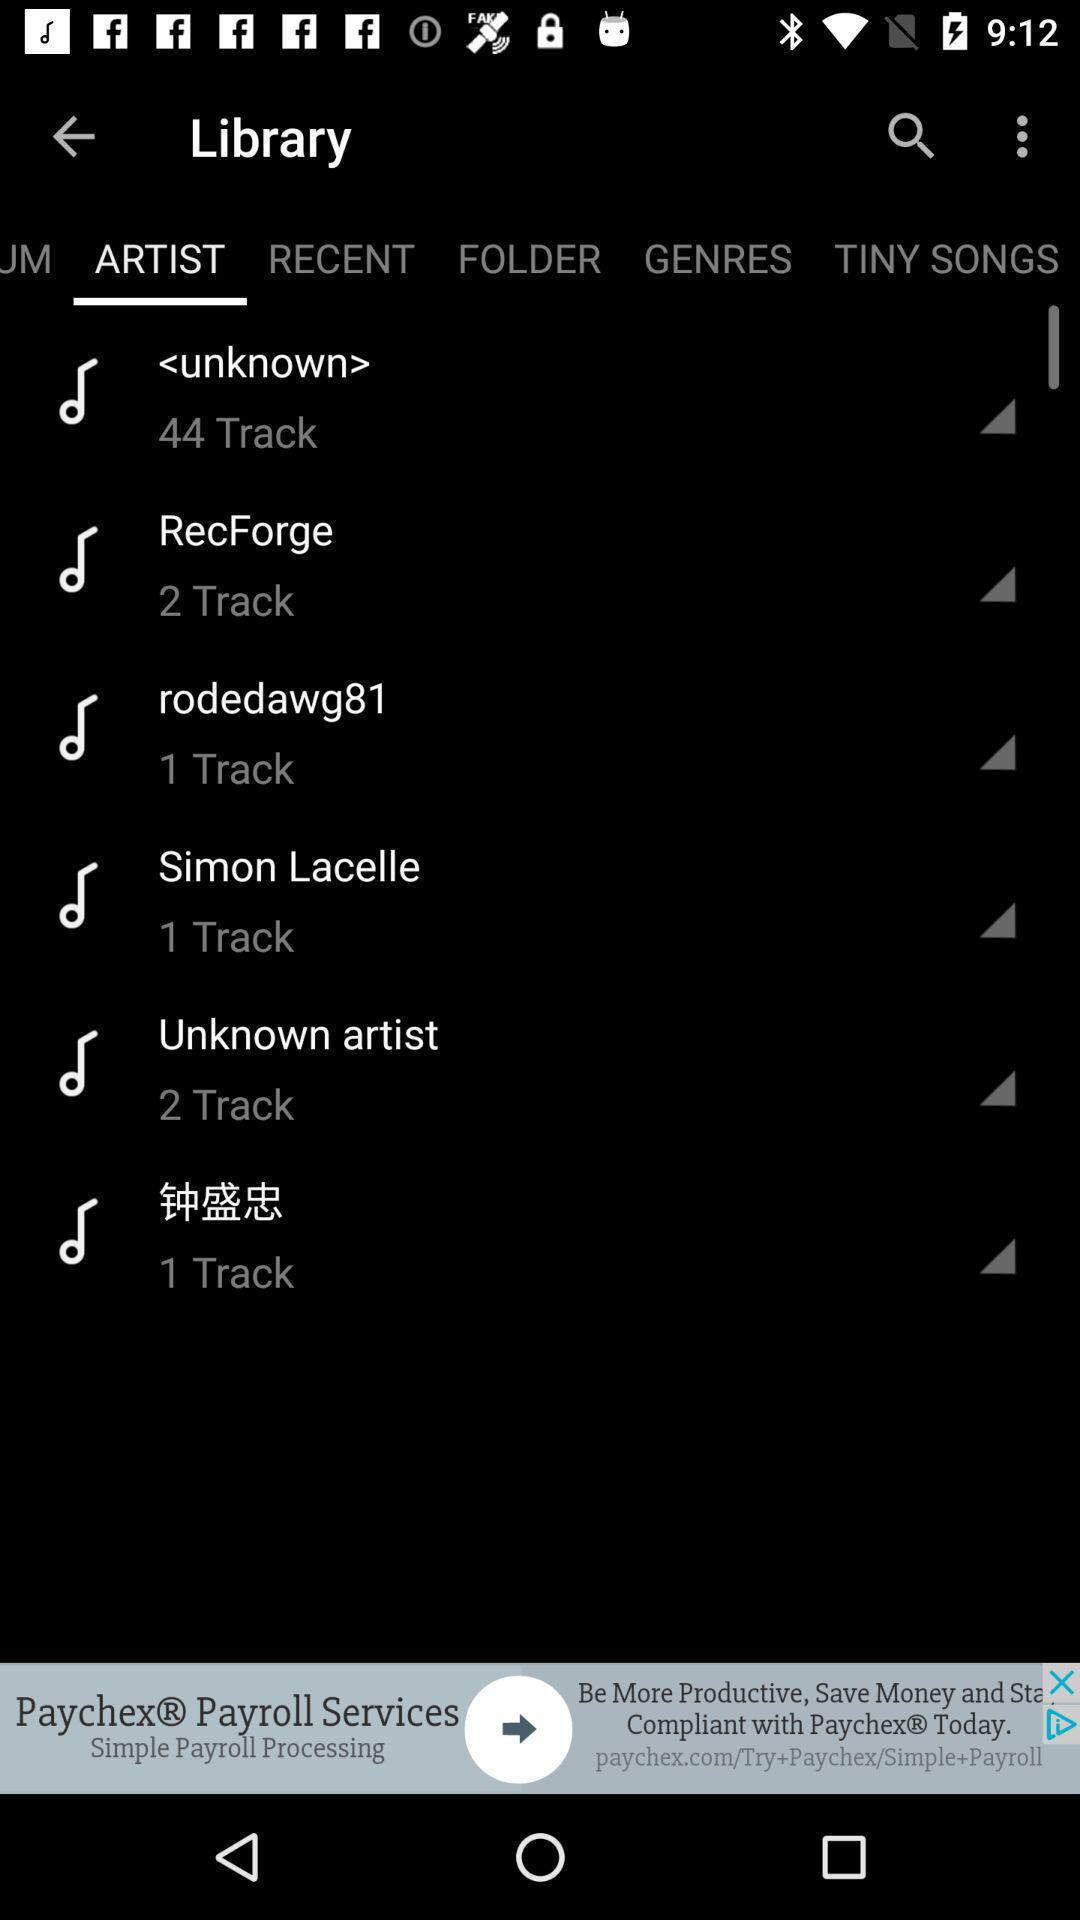Which tab has been selected? The tab "ARTIST" has been selected. 